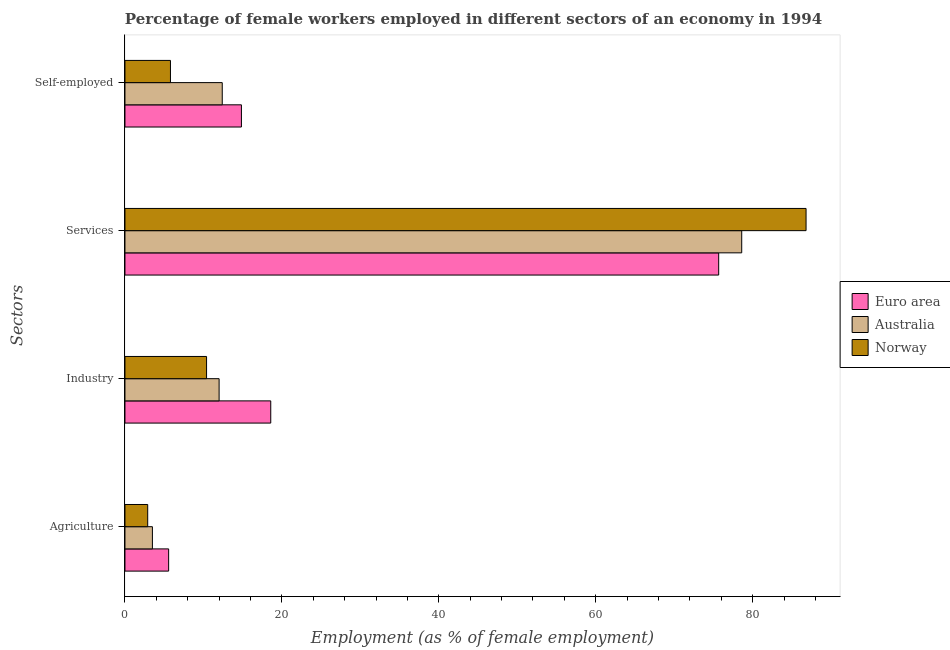Are the number of bars per tick equal to the number of legend labels?
Make the answer very short. Yes. How many bars are there on the 4th tick from the top?
Provide a short and direct response. 3. How many bars are there on the 4th tick from the bottom?
Give a very brief answer. 3. What is the label of the 1st group of bars from the top?
Your response must be concise. Self-employed. What is the percentage of female workers in industry in Euro area?
Provide a succinct answer. 18.58. Across all countries, what is the maximum percentage of self employed female workers?
Ensure brevity in your answer.  14.84. Across all countries, what is the minimum percentage of female workers in industry?
Offer a very short reply. 10.4. In which country was the percentage of female workers in services maximum?
Your answer should be very brief. Norway. In which country was the percentage of female workers in industry minimum?
Your response must be concise. Norway. What is the total percentage of self employed female workers in the graph?
Offer a very short reply. 33.04. What is the difference between the percentage of female workers in agriculture in Australia and that in Norway?
Your response must be concise. 0.6. What is the difference between the percentage of female workers in services in Euro area and the percentage of self employed female workers in Norway?
Your response must be concise. 69.87. What is the average percentage of female workers in services per country?
Ensure brevity in your answer.  80.36. What is the difference between the percentage of self employed female workers and percentage of female workers in agriculture in Norway?
Offer a very short reply. 2.9. In how many countries, is the percentage of female workers in industry greater than 16 %?
Provide a succinct answer. 1. What is the ratio of the percentage of female workers in services in Norway to that in Euro area?
Your response must be concise. 1.15. Is the percentage of female workers in agriculture in Norway less than that in Australia?
Offer a terse response. Yes. Is the difference between the percentage of female workers in industry in Euro area and Norway greater than the difference between the percentage of self employed female workers in Euro area and Norway?
Keep it short and to the point. No. What is the difference between the highest and the second highest percentage of female workers in agriculture?
Ensure brevity in your answer.  2.07. What is the difference between the highest and the lowest percentage of female workers in services?
Provide a short and direct response. 11.13. Is the sum of the percentage of female workers in industry in Euro area and Australia greater than the maximum percentage of female workers in services across all countries?
Offer a very short reply. No. Is it the case that in every country, the sum of the percentage of female workers in agriculture and percentage of female workers in industry is greater than the percentage of female workers in services?
Provide a short and direct response. No. Are all the bars in the graph horizontal?
Your answer should be compact. Yes. How many countries are there in the graph?
Your answer should be compact. 3. What is the difference between two consecutive major ticks on the X-axis?
Keep it short and to the point. 20. Does the graph contain any zero values?
Your answer should be very brief. No. Does the graph contain grids?
Your response must be concise. No. What is the title of the graph?
Provide a succinct answer. Percentage of female workers employed in different sectors of an economy in 1994. Does "Mali" appear as one of the legend labels in the graph?
Keep it short and to the point. No. What is the label or title of the X-axis?
Make the answer very short. Employment (as % of female employment). What is the label or title of the Y-axis?
Give a very brief answer. Sectors. What is the Employment (as % of female employment) of Euro area in Agriculture?
Provide a short and direct response. 5.57. What is the Employment (as % of female employment) in Norway in Agriculture?
Provide a succinct answer. 2.9. What is the Employment (as % of female employment) of Euro area in Industry?
Ensure brevity in your answer.  18.58. What is the Employment (as % of female employment) in Norway in Industry?
Keep it short and to the point. 10.4. What is the Employment (as % of female employment) of Euro area in Services?
Keep it short and to the point. 75.67. What is the Employment (as % of female employment) in Australia in Services?
Give a very brief answer. 78.6. What is the Employment (as % of female employment) in Norway in Services?
Your answer should be compact. 86.8. What is the Employment (as % of female employment) of Euro area in Self-employed?
Provide a succinct answer. 14.84. What is the Employment (as % of female employment) of Australia in Self-employed?
Offer a terse response. 12.4. What is the Employment (as % of female employment) of Norway in Self-employed?
Your response must be concise. 5.8. Across all Sectors, what is the maximum Employment (as % of female employment) of Euro area?
Provide a short and direct response. 75.67. Across all Sectors, what is the maximum Employment (as % of female employment) of Australia?
Offer a very short reply. 78.6. Across all Sectors, what is the maximum Employment (as % of female employment) in Norway?
Keep it short and to the point. 86.8. Across all Sectors, what is the minimum Employment (as % of female employment) of Euro area?
Your answer should be compact. 5.57. Across all Sectors, what is the minimum Employment (as % of female employment) of Norway?
Provide a succinct answer. 2.9. What is the total Employment (as % of female employment) of Euro area in the graph?
Offer a terse response. 114.66. What is the total Employment (as % of female employment) in Australia in the graph?
Offer a very short reply. 106.5. What is the total Employment (as % of female employment) in Norway in the graph?
Give a very brief answer. 105.9. What is the difference between the Employment (as % of female employment) in Euro area in Agriculture and that in Industry?
Offer a terse response. -13.01. What is the difference between the Employment (as % of female employment) in Norway in Agriculture and that in Industry?
Your answer should be compact. -7.5. What is the difference between the Employment (as % of female employment) in Euro area in Agriculture and that in Services?
Keep it short and to the point. -70.1. What is the difference between the Employment (as % of female employment) in Australia in Agriculture and that in Services?
Provide a short and direct response. -75.1. What is the difference between the Employment (as % of female employment) in Norway in Agriculture and that in Services?
Your answer should be compact. -83.9. What is the difference between the Employment (as % of female employment) in Euro area in Agriculture and that in Self-employed?
Provide a short and direct response. -9.27. What is the difference between the Employment (as % of female employment) of Australia in Agriculture and that in Self-employed?
Offer a terse response. -8.9. What is the difference between the Employment (as % of female employment) in Euro area in Industry and that in Services?
Keep it short and to the point. -57.09. What is the difference between the Employment (as % of female employment) of Australia in Industry and that in Services?
Provide a succinct answer. -66.6. What is the difference between the Employment (as % of female employment) in Norway in Industry and that in Services?
Your answer should be very brief. -76.4. What is the difference between the Employment (as % of female employment) in Euro area in Industry and that in Self-employed?
Keep it short and to the point. 3.74. What is the difference between the Employment (as % of female employment) of Euro area in Services and that in Self-employed?
Make the answer very short. 60.82. What is the difference between the Employment (as % of female employment) of Australia in Services and that in Self-employed?
Provide a short and direct response. 66.2. What is the difference between the Employment (as % of female employment) in Euro area in Agriculture and the Employment (as % of female employment) in Australia in Industry?
Offer a very short reply. -6.43. What is the difference between the Employment (as % of female employment) in Euro area in Agriculture and the Employment (as % of female employment) in Norway in Industry?
Keep it short and to the point. -4.83. What is the difference between the Employment (as % of female employment) of Euro area in Agriculture and the Employment (as % of female employment) of Australia in Services?
Make the answer very short. -73.03. What is the difference between the Employment (as % of female employment) in Euro area in Agriculture and the Employment (as % of female employment) in Norway in Services?
Your answer should be very brief. -81.23. What is the difference between the Employment (as % of female employment) of Australia in Agriculture and the Employment (as % of female employment) of Norway in Services?
Offer a very short reply. -83.3. What is the difference between the Employment (as % of female employment) of Euro area in Agriculture and the Employment (as % of female employment) of Australia in Self-employed?
Provide a short and direct response. -6.83. What is the difference between the Employment (as % of female employment) of Euro area in Agriculture and the Employment (as % of female employment) of Norway in Self-employed?
Your response must be concise. -0.23. What is the difference between the Employment (as % of female employment) of Euro area in Industry and the Employment (as % of female employment) of Australia in Services?
Provide a succinct answer. -60.02. What is the difference between the Employment (as % of female employment) of Euro area in Industry and the Employment (as % of female employment) of Norway in Services?
Provide a succinct answer. -68.22. What is the difference between the Employment (as % of female employment) in Australia in Industry and the Employment (as % of female employment) in Norway in Services?
Your answer should be very brief. -74.8. What is the difference between the Employment (as % of female employment) in Euro area in Industry and the Employment (as % of female employment) in Australia in Self-employed?
Offer a very short reply. 6.18. What is the difference between the Employment (as % of female employment) in Euro area in Industry and the Employment (as % of female employment) in Norway in Self-employed?
Keep it short and to the point. 12.78. What is the difference between the Employment (as % of female employment) in Euro area in Services and the Employment (as % of female employment) in Australia in Self-employed?
Your response must be concise. 63.27. What is the difference between the Employment (as % of female employment) of Euro area in Services and the Employment (as % of female employment) of Norway in Self-employed?
Your answer should be very brief. 69.87. What is the difference between the Employment (as % of female employment) in Australia in Services and the Employment (as % of female employment) in Norway in Self-employed?
Provide a succinct answer. 72.8. What is the average Employment (as % of female employment) in Euro area per Sectors?
Ensure brevity in your answer.  28.66. What is the average Employment (as % of female employment) in Australia per Sectors?
Provide a short and direct response. 26.62. What is the average Employment (as % of female employment) in Norway per Sectors?
Ensure brevity in your answer.  26.48. What is the difference between the Employment (as % of female employment) in Euro area and Employment (as % of female employment) in Australia in Agriculture?
Make the answer very short. 2.07. What is the difference between the Employment (as % of female employment) of Euro area and Employment (as % of female employment) of Norway in Agriculture?
Provide a short and direct response. 2.67. What is the difference between the Employment (as % of female employment) of Australia and Employment (as % of female employment) of Norway in Agriculture?
Your answer should be compact. 0.6. What is the difference between the Employment (as % of female employment) of Euro area and Employment (as % of female employment) of Australia in Industry?
Keep it short and to the point. 6.58. What is the difference between the Employment (as % of female employment) of Euro area and Employment (as % of female employment) of Norway in Industry?
Offer a very short reply. 8.18. What is the difference between the Employment (as % of female employment) in Euro area and Employment (as % of female employment) in Australia in Services?
Give a very brief answer. -2.93. What is the difference between the Employment (as % of female employment) of Euro area and Employment (as % of female employment) of Norway in Services?
Make the answer very short. -11.13. What is the difference between the Employment (as % of female employment) of Australia and Employment (as % of female employment) of Norway in Services?
Your response must be concise. -8.2. What is the difference between the Employment (as % of female employment) of Euro area and Employment (as % of female employment) of Australia in Self-employed?
Your answer should be very brief. 2.44. What is the difference between the Employment (as % of female employment) of Euro area and Employment (as % of female employment) of Norway in Self-employed?
Give a very brief answer. 9.04. What is the difference between the Employment (as % of female employment) in Australia and Employment (as % of female employment) in Norway in Self-employed?
Your response must be concise. 6.6. What is the ratio of the Employment (as % of female employment) of Euro area in Agriculture to that in Industry?
Your response must be concise. 0.3. What is the ratio of the Employment (as % of female employment) of Australia in Agriculture to that in Industry?
Your response must be concise. 0.29. What is the ratio of the Employment (as % of female employment) in Norway in Agriculture to that in Industry?
Offer a very short reply. 0.28. What is the ratio of the Employment (as % of female employment) of Euro area in Agriculture to that in Services?
Your answer should be compact. 0.07. What is the ratio of the Employment (as % of female employment) in Australia in Agriculture to that in Services?
Your answer should be compact. 0.04. What is the ratio of the Employment (as % of female employment) of Norway in Agriculture to that in Services?
Provide a succinct answer. 0.03. What is the ratio of the Employment (as % of female employment) of Euro area in Agriculture to that in Self-employed?
Provide a succinct answer. 0.38. What is the ratio of the Employment (as % of female employment) of Australia in Agriculture to that in Self-employed?
Provide a succinct answer. 0.28. What is the ratio of the Employment (as % of female employment) in Euro area in Industry to that in Services?
Your response must be concise. 0.25. What is the ratio of the Employment (as % of female employment) in Australia in Industry to that in Services?
Provide a succinct answer. 0.15. What is the ratio of the Employment (as % of female employment) of Norway in Industry to that in Services?
Your answer should be very brief. 0.12. What is the ratio of the Employment (as % of female employment) of Euro area in Industry to that in Self-employed?
Offer a very short reply. 1.25. What is the ratio of the Employment (as % of female employment) in Australia in Industry to that in Self-employed?
Your answer should be very brief. 0.97. What is the ratio of the Employment (as % of female employment) of Norway in Industry to that in Self-employed?
Make the answer very short. 1.79. What is the ratio of the Employment (as % of female employment) of Euro area in Services to that in Self-employed?
Your answer should be compact. 5.1. What is the ratio of the Employment (as % of female employment) of Australia in Services to that in Self-employed?
Ensure brevity in your answer.  6.34. What is the ratio of the Employment (as % of female employment) of Norway in Services to that in Self-employed?
Ensure brevity in your answer.  14.97. What is the difference between the highest and the second highest Employment (as % of female employment) of Euro area?
Ensure brevity in your answer.  57.09. What is the difference between the highest and the second highest Employment (as % of female employment) of Australia?
Your answer should be very brief. 66.2. What is the difference between the highest and the second highest Employment (as % of female employment) of Norway?
Make the answer very short. 76.4. What is the difference between the highest and the lowest Employment (as % of female employment) of Euro area?
Offer a terse response. 70.1. What is the difference between the highest and the lowest Employment (as % of female employment) of Australia?
Provide a short and direct response. 75.1. What is the difference between the highest and the lowest Employment (as % of female employment) of Norway?
Provide a succinct answer. 83.9. 